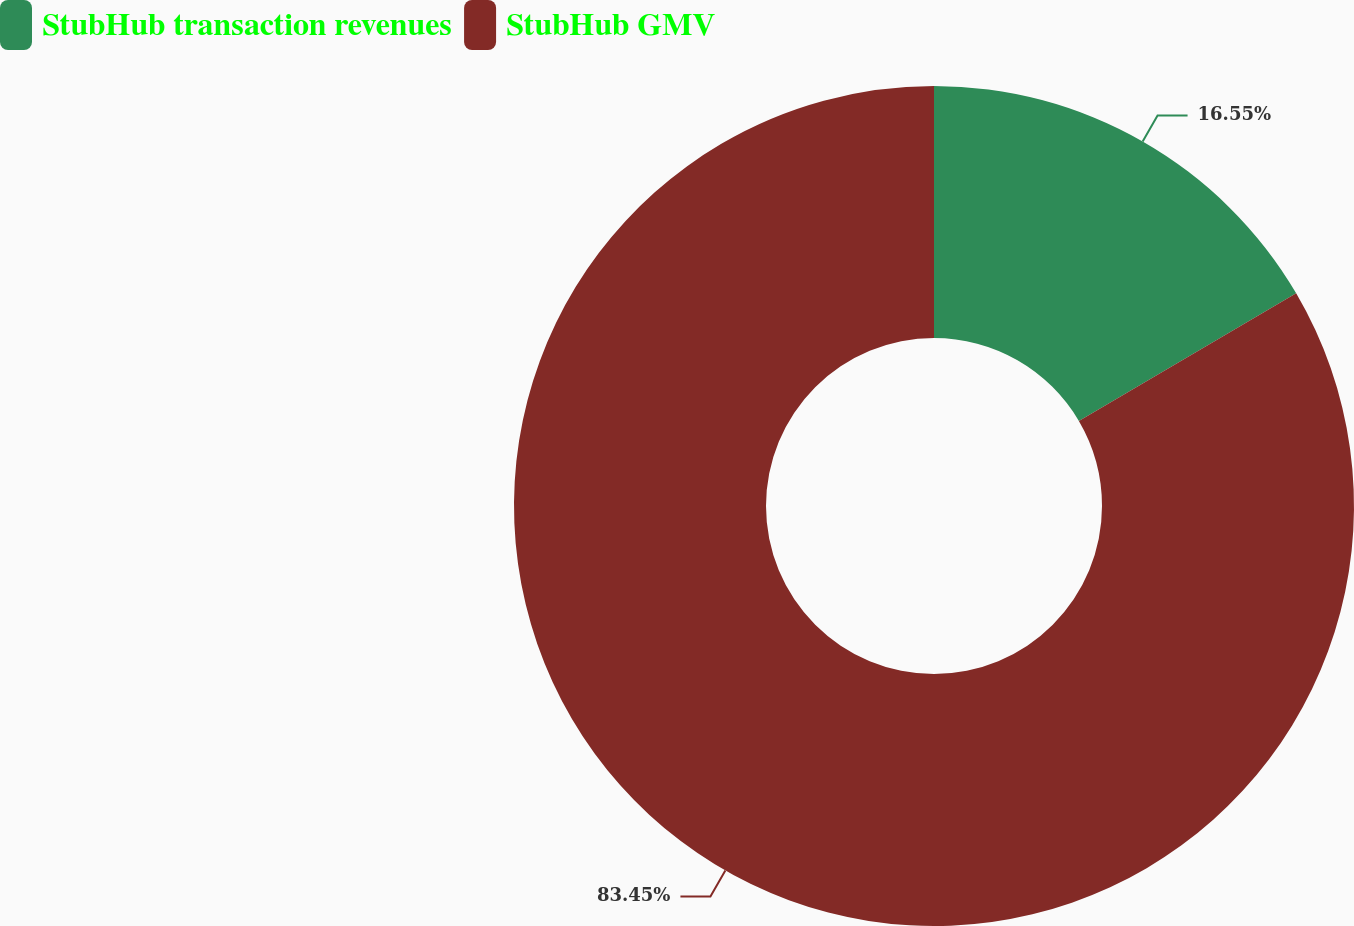Convert chart. <chart><loc_0><loc_0><loc_500><loc_500><pie_chart><fcel>StubHub transaction revenues<fcel>StubHub GMV<nl><fcel>16.55%<fcel>83.45%<nl></chart> 